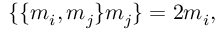<formula> <loc_0><loc_0><loc_500><loc_500>\{ \{ m _ { i } , m _ { j } \} m _ { j } \} = 2 m _ { i } ,</formula> 